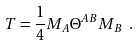Convert formula to latex. <formula><loc_0><loc_0><loc_500><loc_500>T = \frac { 1 } { 4 } M _ { A } \Theta ^ { A B } M _ { B } \ .</formula> 